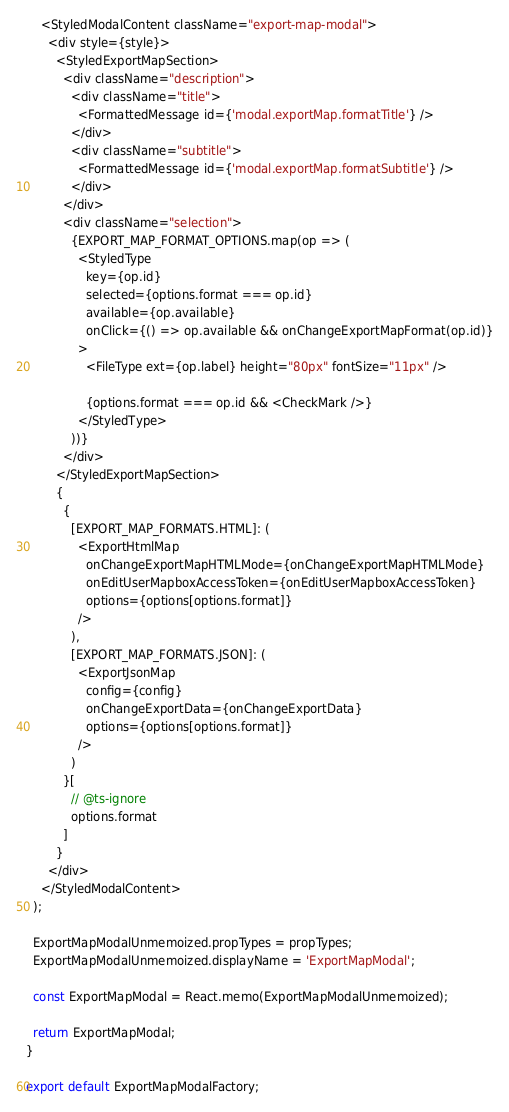Convert code to text. <code><loc_0><loc_0><loc_500><loc_500><_JavaScript_>    <StyledModalContent className="export-map-modal">
      <div style={style}>
        <StyledExportMapSection>
          <div className="description">
            <div className="title">
              <FormattedMessage id={'modal.exportMap.formatTitle'} />
            </div>
            <div className="subtitle">
              <FormattedMessage id={'modal.exportMap.formatSubtitle'} />
            </div>
          </div>
          <div className="selection">
            {EXPORT_MAP_FORMAT_OPTIONS.map(op => (
              <StyledType
                key={op.id}
                selected={options.format === op.id}
                available={op.available}
                onClick={() => op.available && onChangeExportMapFormat(op.id)}
              >
                <FileType ext={op.label} height="80px" fontSize="11px" />

                {options.format === op.id && <CheckMark />}
              </StyledType>
            ))}
          </div>
        </StyledExportMapSection>
        {
          {
            [EXPORT_MAP_FORMATS.HTML]: (
              <ExportHtmlMap
                onChangeExportMapHTMLMode={onChangeExportMapHTMLMode}
                onEditUserMapboxAccessToken={onEditUserMapboxAccessToken}
                options={options[options.format]}
              />
            ),
            [EXPORT_MAP_FORMATS.JSON]: (
              <ExportJsonMap
                config={config}
                onChangeExportData={onChangeExportData}
                options={options[options.format]}
              />
            )
          }[
            // @ts-ignore
            options.format
          ]
        }
      </div>
    </StyledModalContent>
  );

  ExportMapModalUnmemoized.propTypes = propTypes;
  ExportMapModalUnmemoized.displayName = 'ExportMapModal';

  const ExportMapModal = React.memo(ExportMapModalUnmemoized);

  return ExportMapModal;
}

export default ExportMapModalFactory;
</code> 